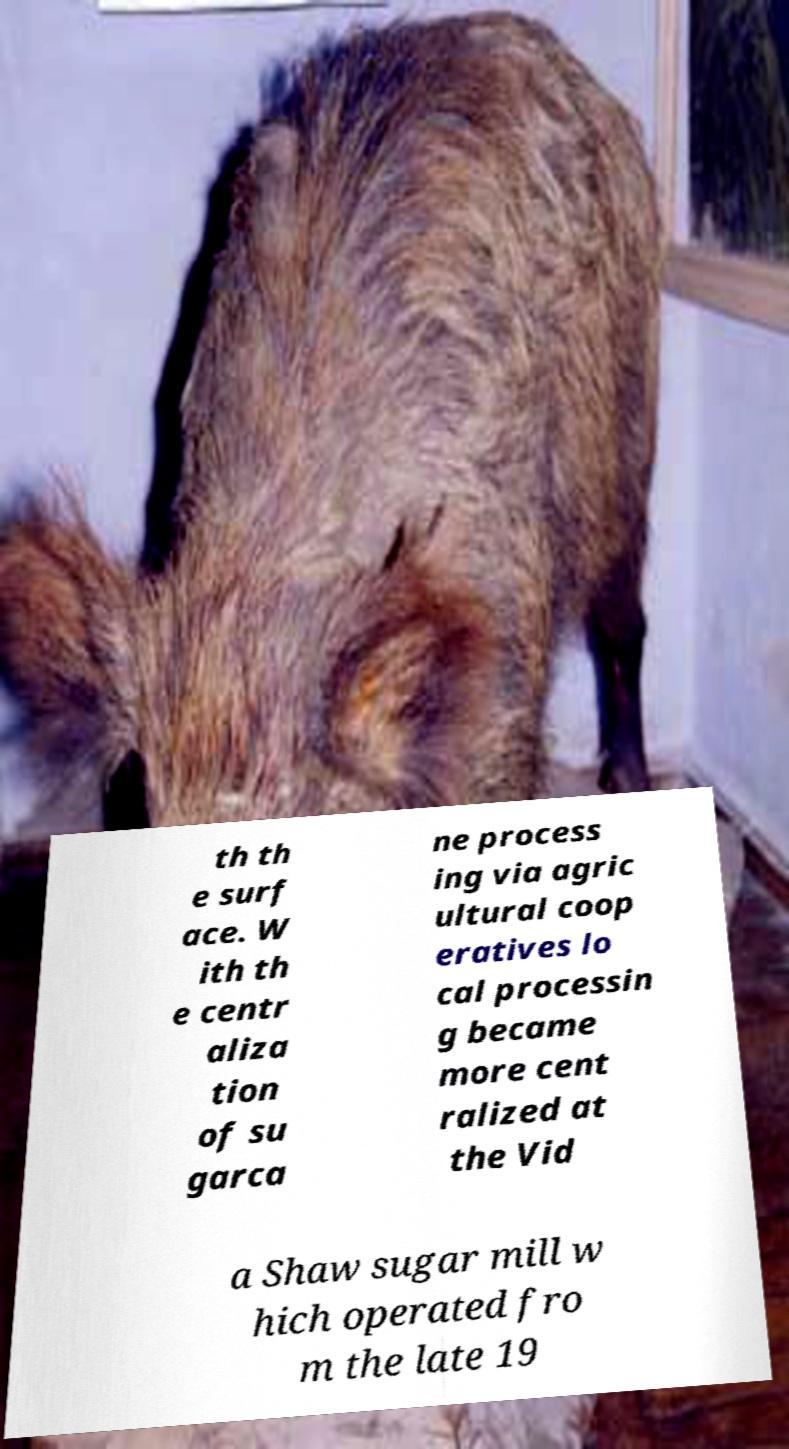Could you extract and type out the text from this image? th th e surf ace. W ith th e centr aliza tion of su garca ne process ing via agric ultural coop eratives lo cal processin g became more cent ralized at the Vid a Shaw sugar mill w hich operated fro m the late 19 